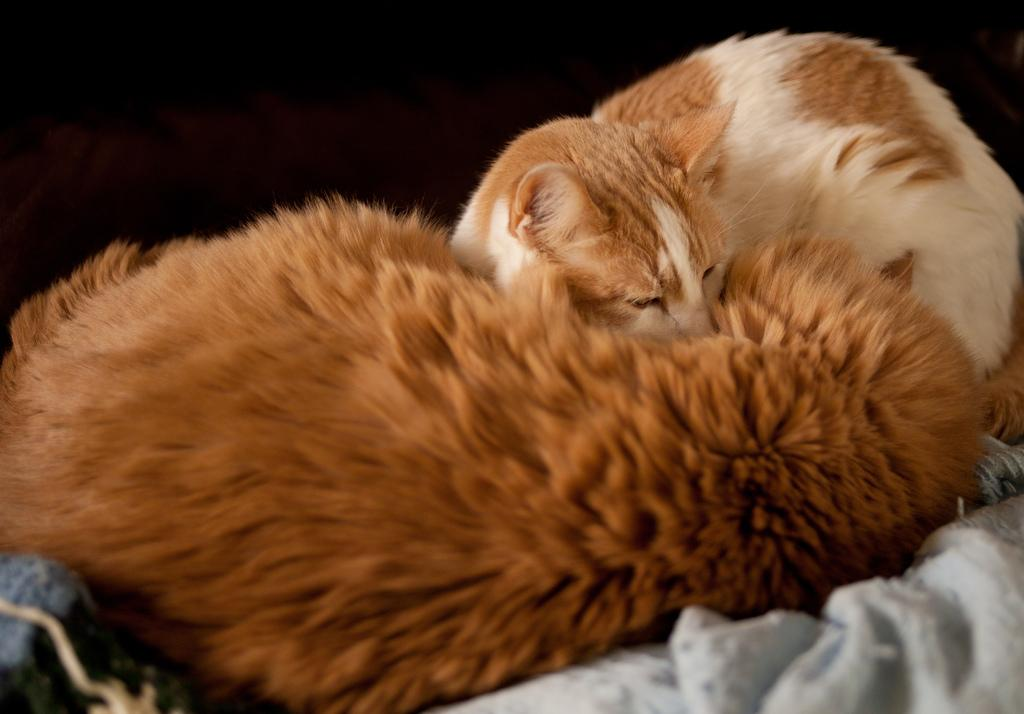What type of animals are in the image? There are cats in the image. What material is present in the image? There is cloth in the image. What is the color of the background in the image? The background of the image is dark. What type of sock is visible on the cats in the image? There are no socks visible on the cats in the image. How many horses are present in the image? There are no horses present in the image. What type of oil is being used by the cats in the image? There is no oil present in the image. 